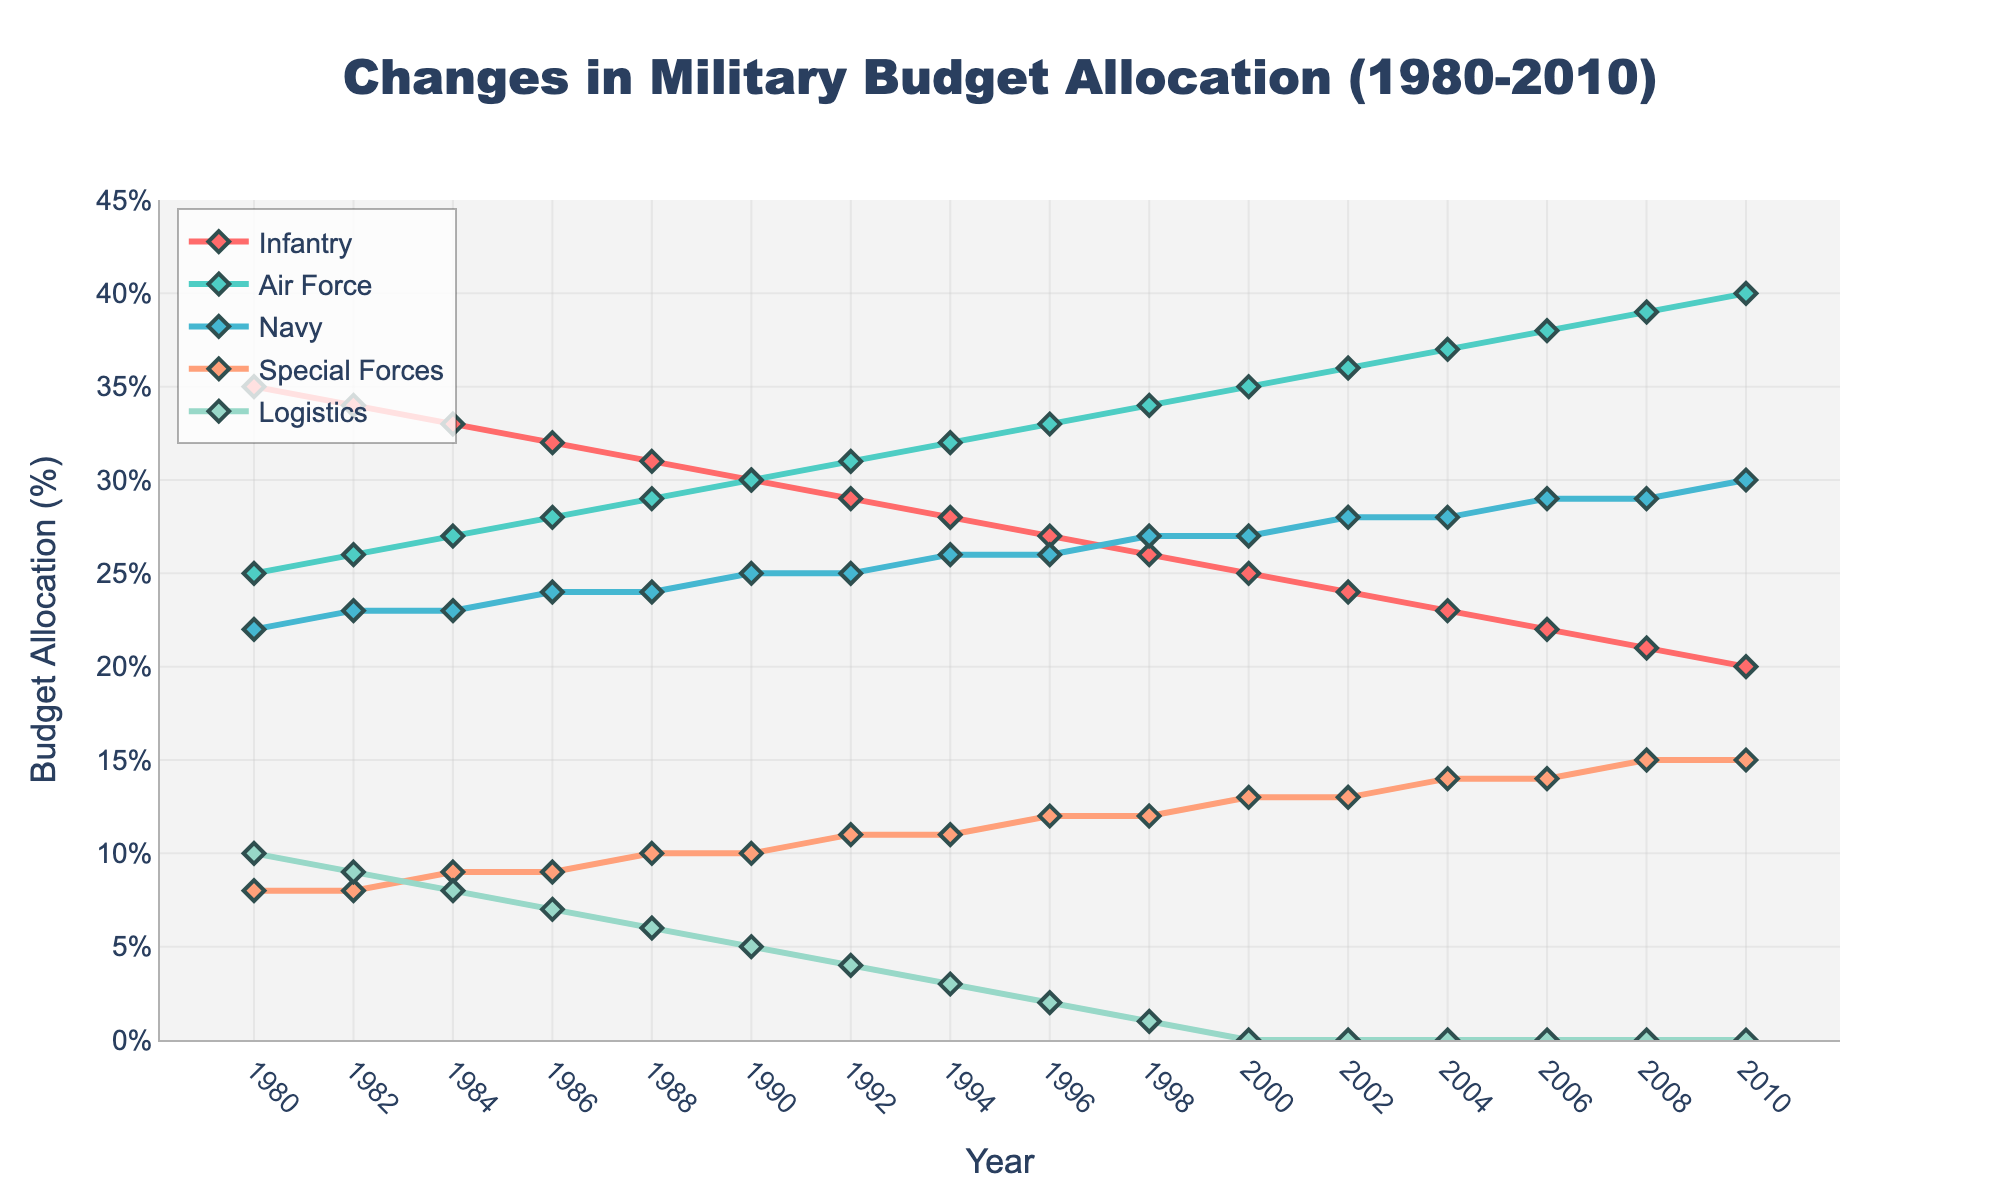what is the overall trend for the Infantry budget allocation from 1980 to 2010? The data shows a steady decrease in the percentage allocated to Infantry over the years from 35% in 1980 to 20% in 2010.
Answer: decreasing How does the budget allocation for the Air Force in 1980 compare to that in 2010? In 1980, the budget allocation for the Air Force was 25%, while in 2010, it had increased to 40%.
Answer: increased In which year did the Navy's budget allocation first reach 27%? By inspecting the lines, the Navy's allocation reached 27% in 1998 and stayed constant after that.
Answer: 1998 What are the respective budget allocations for Special Forces and Logistics in 2000? In 2000, the allocation for Special Forces was 13% and for Logistics was 0%.
Answer: Special Forces: 13%, Logistics: 0% On average, what was the budget allocation for the Air Force between 1980 and 2010? To find the average: (25 + 26 + 27 + 28 + 29 + 30 + 31 + 32 + 33 + 34 + 35 + 36 + 37 + 38 + 39 + 40) / 16 = 32.
Answer: 32% Which department had the largest decrease in budget allocation from start to end? Comparing the initial and final values for each department, Infantry decreased the most from 35% to 20%, a reduction of 15%.
Answer: Infantry In what year was the budget allocation for the Air Force equal to that of the Infantry? The budget allocations for Infantry and Air Force were both 30% in the year 1990.
Answer: 1990 By how many percentage points did the budget allocation for Special Forces increase from 1980 to 2010? Special Forces had an increase from 8% in 1980 to 15% in 2010, making it a 7 percentage point increase.
Answer: 7 Which department shows a continuous non-zero allocation throughout the entire period? Departments other than Logistics have non-zero values consistently shown in all the years, but Special Forces stand out for continuous and increasing allocation.
Answer: Special Forces When did Logistics' budget allocation reach zero and remain zero for the first time? Logistics' budget allocation reached zero in 2000 and remained zero from that point onward.
Answer: 2000 